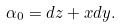<formula> <loc_0><loc_0><loc_500><loc_500>\alpha _ { 0 } = d z + x d y .</formula> 